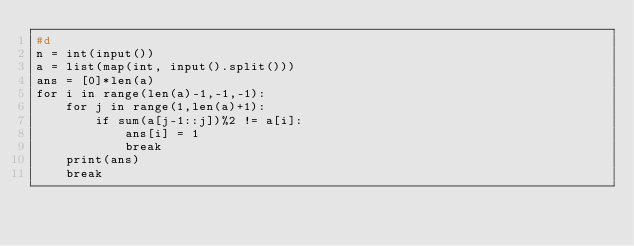<code> <loc_0><loc_0><loc_500><loc_500><_Python_>#d
n = int(input())
a = list(map(int, input().split()))
ans = [0]*len(a)
for i in range(len(a)-1,-1,-1):
    for j in range(1,len(a)+1):
        if sum(a[j-1::j])%2 != a[i]:
            ans[i] = 1
            break
    print(ans)
    break</code> 